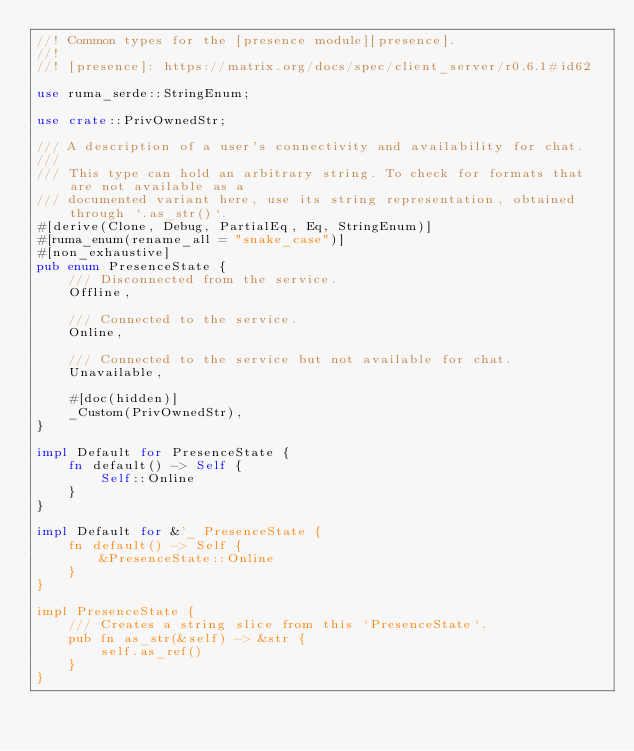Convert code to text. <code><loc_0><loc_0><loc_500><loc_500><_Rust_>//! Common types for the [presence module][presence].
//!
//! [presence]: https://matrix.org/docs/spec/client_server/r0.6.1#id62

use ruma_serde::StringEnum;

use crate::PrivOwnedStr;

/// A description of a user's connectivity and availability for chat.
///
/// This type can hold an arbitrary string. To check for formats that are not available as a
/// documented variant here, use its string representation, obtained through `.as_str()`.
#[derive(Clone, Debug, PartialEq, Eq, StringEnum)]
#[ruma_enum(rename_all = "snake_case")]
#[non_exhaustive]
pub enum PresenceState {
    /// Disconnected from the service.
    Offline,

    /// Connected to the service.
    Online,

    /// Connected to the service but not available for chat.
    Unavailable,

    #[doc(hidden)]
    _Custom(PrivOwnedStr),
}

impl Default for PresenceState {
    fn default() -> Self {
        Self::Online
    }
}

impl Default for &'_ PresenceState {
    fn default() -> Self {
        &PresenceState::Online
    }
}

impl PresenceState {
    /// Creates a string slice from this `PresenceState`.
    pub fn as_str(&self) -> &str {
        self.as_ref()
    }
}
</code> 